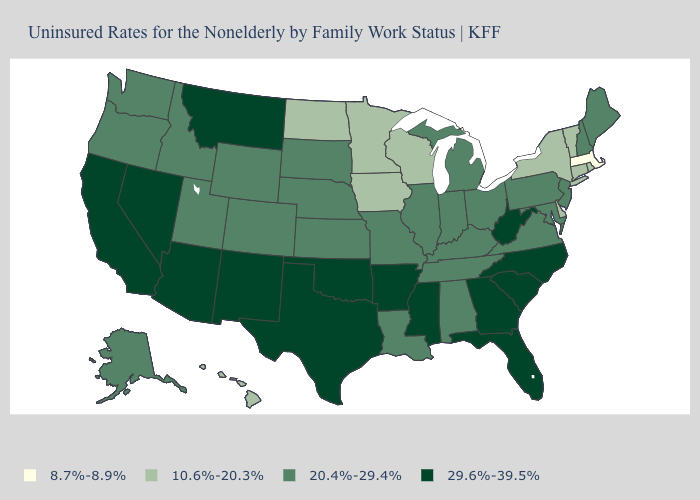What is the value of Tennessee?
Keep it brief. 20.4%-29.4%. What is the value of South Carolina?
Write a very short answer. 29.6%-39.5%. Among the states that border Oklahoma , which have the highest value?
Short answer required. Arkansas, New Mexico, Texas. Name the states that have a value in the range 8.7%-8.9%?
Answer briefly. Massachusetts. Among the states that border Maine , which have the highest value?
Be succinct. New Hampshire. Does Kentucky have the same value as Texas?
Concise answer only. No. Among the states that border Delaware , which have the highest value?
Short answer required. Maryland, New Jersey, Pennsylvania. Which states have the highest value in the USA?
Quick response, please. Arizona, Arkansas, California, Florida, Georgia, Mississippi, Montana, Nevada, New Mexico, North Carolina, Oklahoma, South Carolina, Texas, West Virginia. Which states have the highest value in the USA?
Quick response, please. Arizona, Arkansas, California, Florida, Georgia, Mississippi, Montana, Nevada, New Mexico, North Carolina, Oklahoma, South Carolina, Texas, West Virginia. Among the states that border Iowa , which have the lowest value?
Short answer required. Minnesota, Wisconsin. What is the value of Alaska?
Short answer required. 20.4%-29.4%. What is the value of Mississippi?
Keep it brief. 29.6%-39.5%. Name the states that have a value in the range 20.4%-29.4%?
Give a very brief answer. Alabama, Alaska, Colorado, Idaho, Illinois, Indiana, Kansas, Kentucky, Louisiana, Maine, Maryland, Michigan, Missouri, Nebraska, New Hampshire, New Jersey, Ohio, Oregon, Pennsylvania, South Dakota, Tennessee, Utah, Virginia, Washington, Wyoming. What is the lowest value in the South?
Give a very brief answer. 10.6%-20.3%. What is the value of Iowa?
Answer briefly. 10.6%-20.3%. 